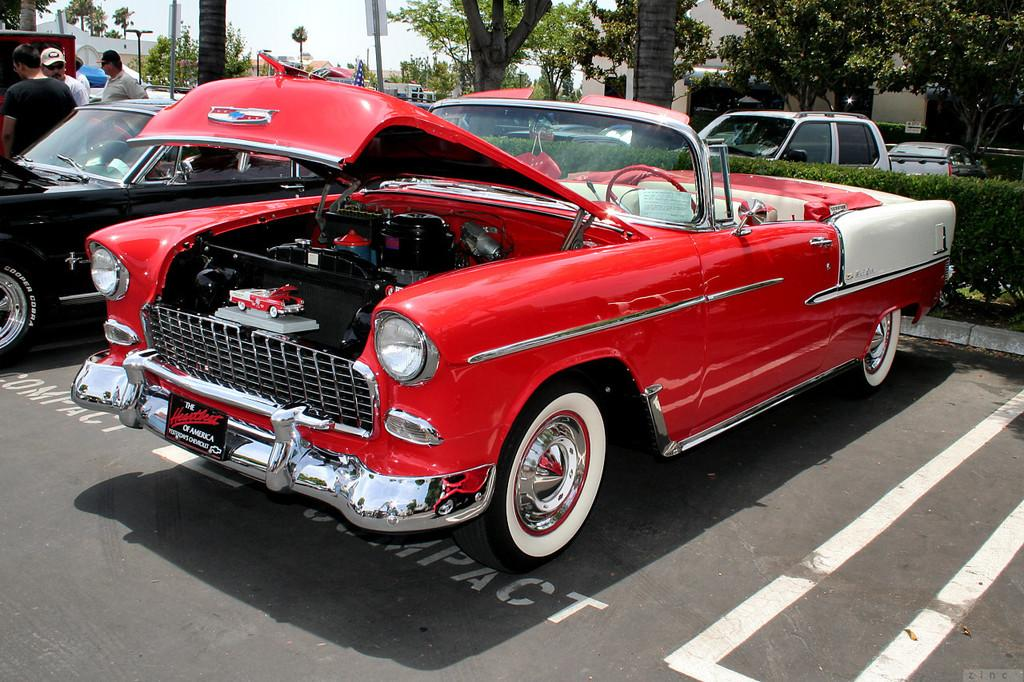What can be seen on the road in the image? There are cars on the road in the image. What is located on the left side of the image? There are people on the left side of the image. What type of natural elements can be seen in the background of the image? There are trees in the background of the image. What else can be seen in the background of the image? There are poles and buildings in the background of the image. What part of the natural environment is visible in the image? The sky is visible in the background of the image. Where is the vase located in the image? There is no vase present in the image. What type of art can be seen on the buildings in the image? There is no specific art visible on the buildings in the image; only the buildings themselves are mentioned. 